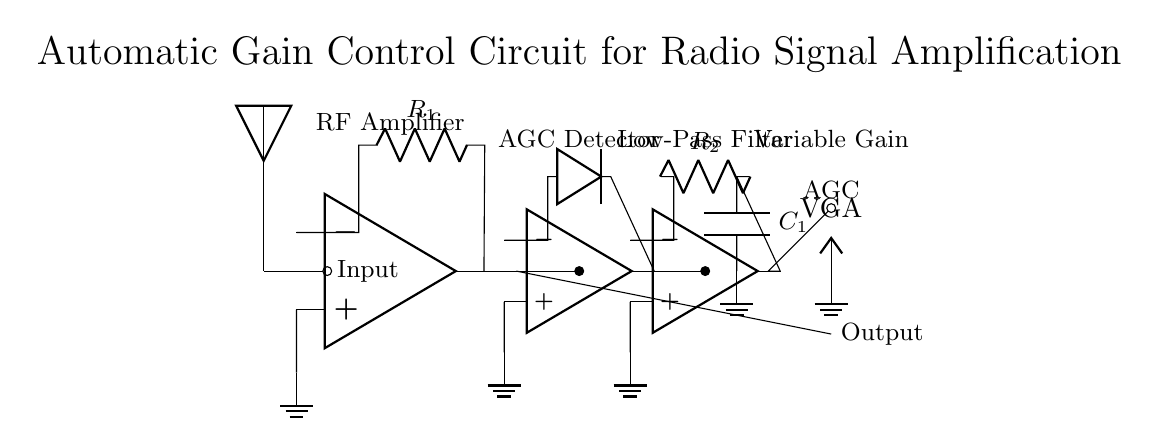What type of amplifier is used in this circuit? The circuit includes a radio frequency amplifier, indicated by the operational amplifier symbol labeled as "RF Amplifier."
Answer: RF amplifier What is the purpose of the AGC detector in this circuit? The AGC detector is used to monitor the output signal level and adjust gain accordingly, making it critical for maintaining constant output levels.
Answer: To adjust gain What components form the low-pass filter in this circuit? The low-pass filter in this circuit is formed by the resistor labeled "R2" and the capacitor labeled "C1," which are connected in series, followed by a ground connection.
Answer: R2 and C1 How many operational amplifiers are present in this circuit? The circuit contains three operational amplifiers: one for RF amplification, one for AGC detection, and one within the low-pass filter.
Answer: Three What does "VGA" stand for in this circuit? "VGA" stands for Variable Gain Amplifier, which adjusts the level of the output signal based on the control input received from the AGC detector.
Answer: Variable Gain Amplifier What is the output of this circuit labeled as? The output of the circuit is labeled simply as "Output," indicating the final amplified signal ready for transmission or further processing.
Answer: Output 